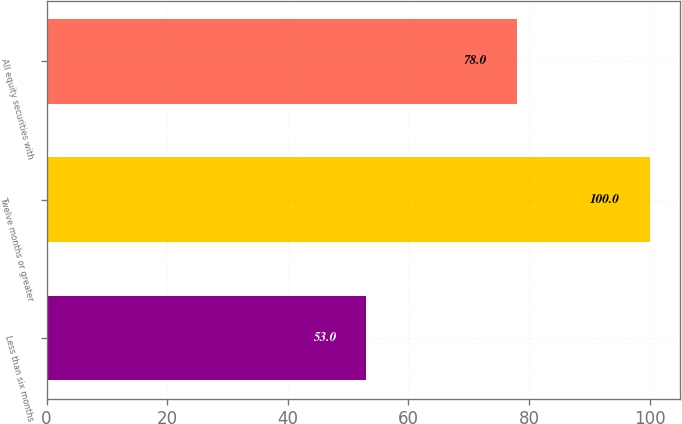Convert chart. <chart><loc_0><loc_0><loc_500><loc_500><bar_chart><fcel>Less than six months<fcel>Twelve months or greater<fcel>All equity securities with<nl><fcel>53<fcel>100<fcel>78<nl></chart> 